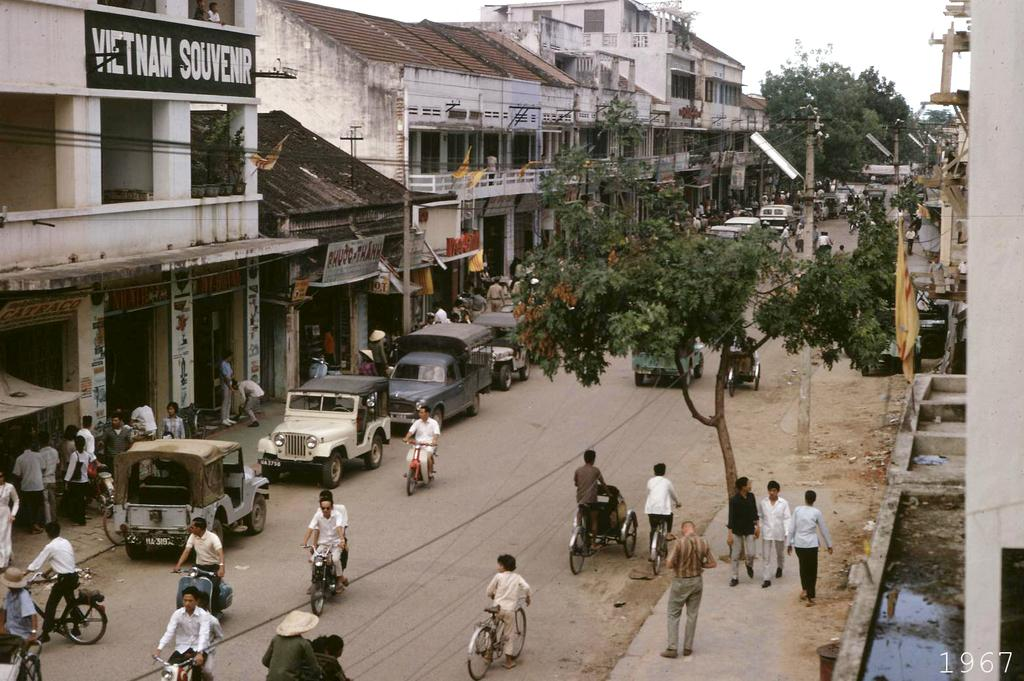<image>
Share a concise interpretation of the image provided. On a run down street a large sign reads Vietnam Souvenir. 